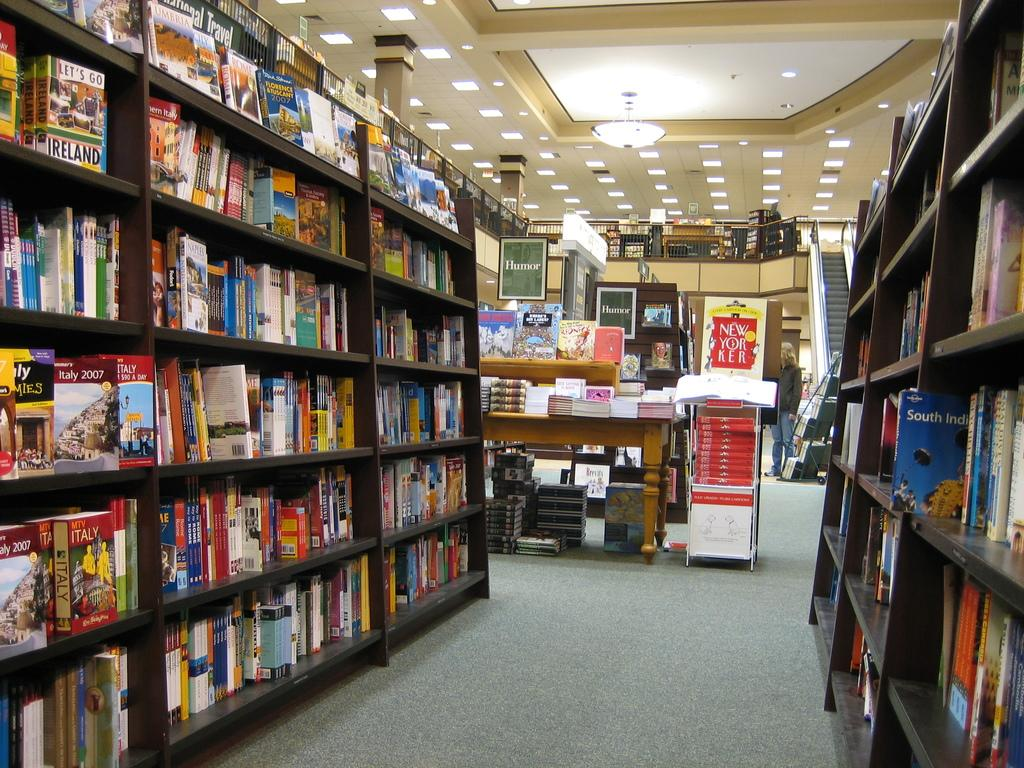Provide a one-sentence caption for the provided image. Library with a book titled "Let's Go Ireland" on the shelf. 